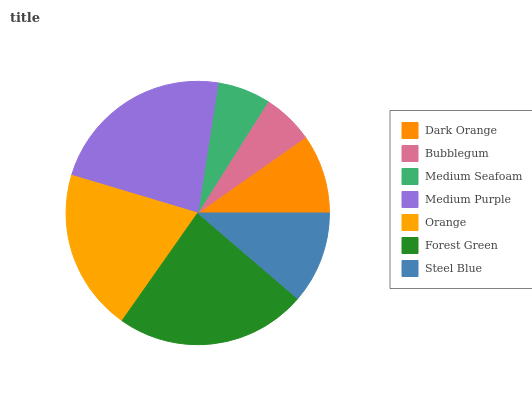Is Bubblegum the minimum?
Answer yes or no. Yes. Is Forest Green the maximum?
Answer yes or no. Yes. Is Medium Seafoam the minimum?
Answer yes or no. No. Is Medium Seafoam the maximum?
Answer yes or no. No. Is Medium Seafoam greater than Bubblegum?
Answer yes or no. Yes. Is Bubblegum less than Medium Seafoam?
Answer yes or no. Yes. Is Bubblegum greater than Medium Seafoam?
Answer yes or no. No. Is Medium Seafoam less than Bubblegum?
Answer yes or no. No. Is Steel Blue the high median?
Answer yes or no. Yes. Is Steel Blue the low median?
Answer yes or no. Yes. Is Medium Purple the high median?
Answer yes or no. No. Is Forest Green the low median?
Answer yes or no. No. 